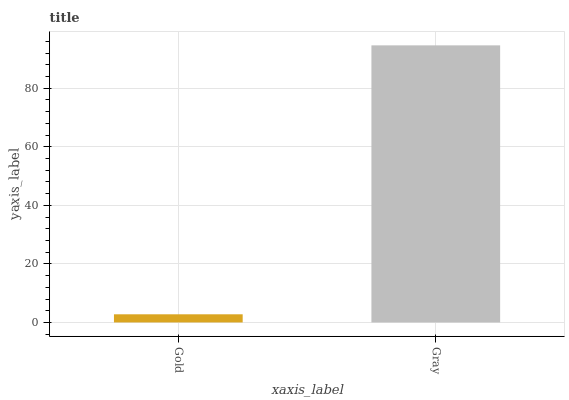Is Gray the minimum?
Answer yes or no. No. Is Gray greater than Gold?
Answer yes or no. Yes. Is Gold less than Gray?
Answer yes or no. Yes. Is Gold greater than Gray?
Answer yes or no. No. Is Gray less than Gold?
Answer yes or no. No. Is Gray the high median?
Answer yes or no. Yes. Is Gold the low median?
Answer yes or no. Yes. Is Gold the high median?
Answer yes or no. No. Is Gray the low median?
Answer yes or no. No. 